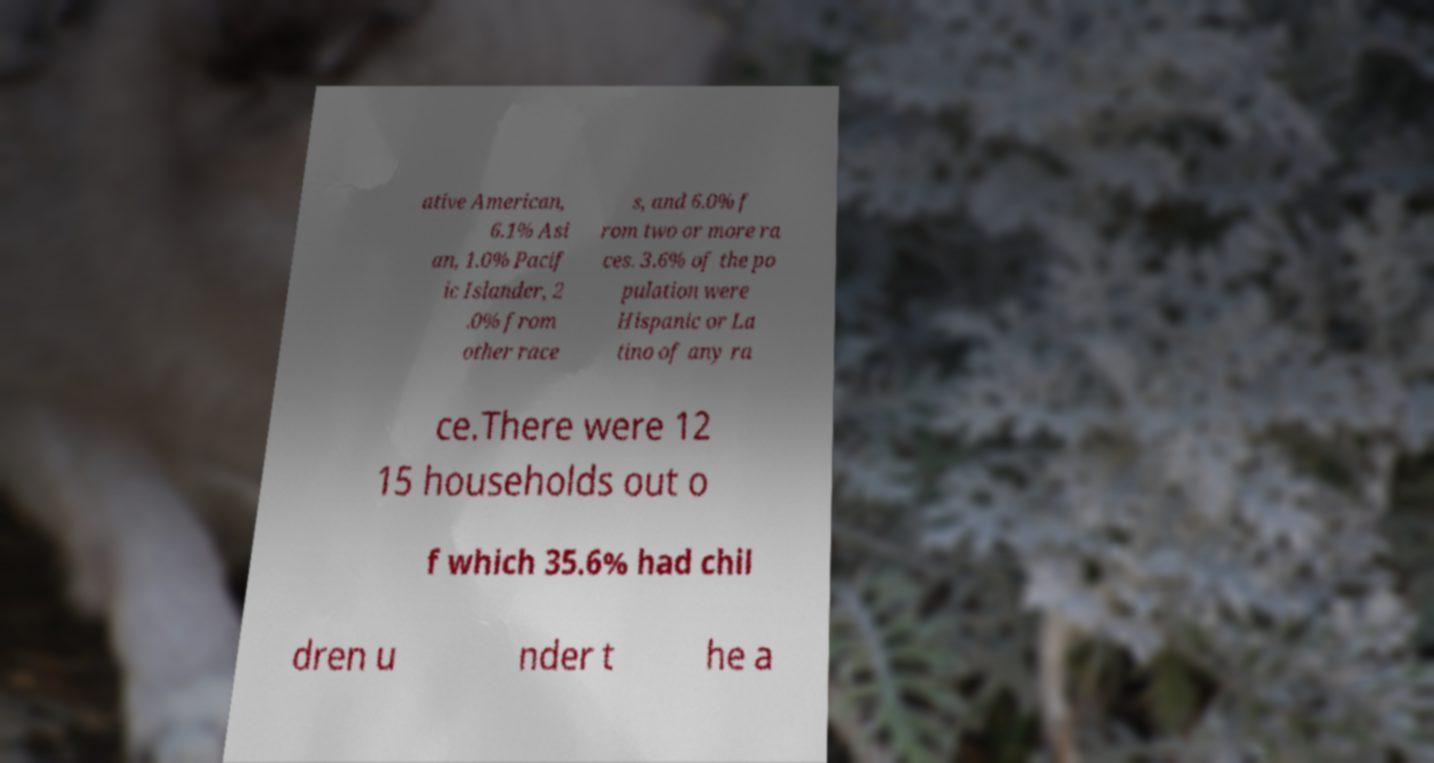Please identify and transcribe the text found in this image. ative American, 6.1% Asi an, 1.0% Pacif ic Islander, 2 .0% from other race s, and 6.0% f rom two or more ra ces. 3.6% of the po pulation were Hispanic or La tino of any ra ce.There were 12 15 households out o f which 35.6% had chil dren u nder t he a 